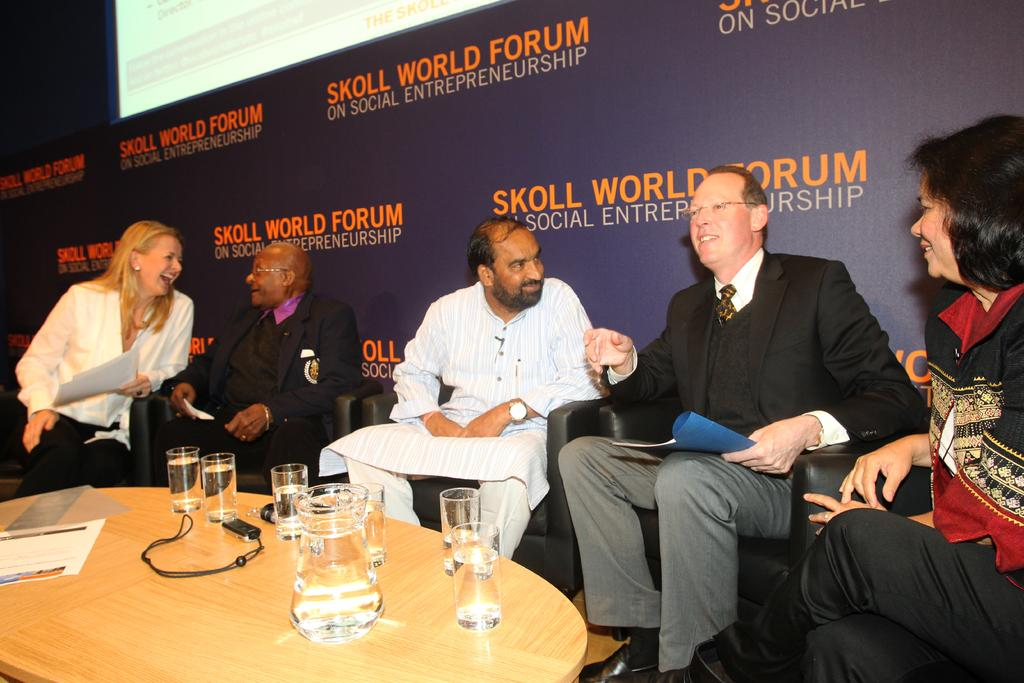What are the people in the image doing? The people in the image are sitting on chairs. What can be seen on the table in the image? There is a water jug and glasses filled with water on the table. What type of government is depicted in the image? There is no depiction of a government in the image; it features people sitting on chairs and a table with a water jug and glasses filled with water. 